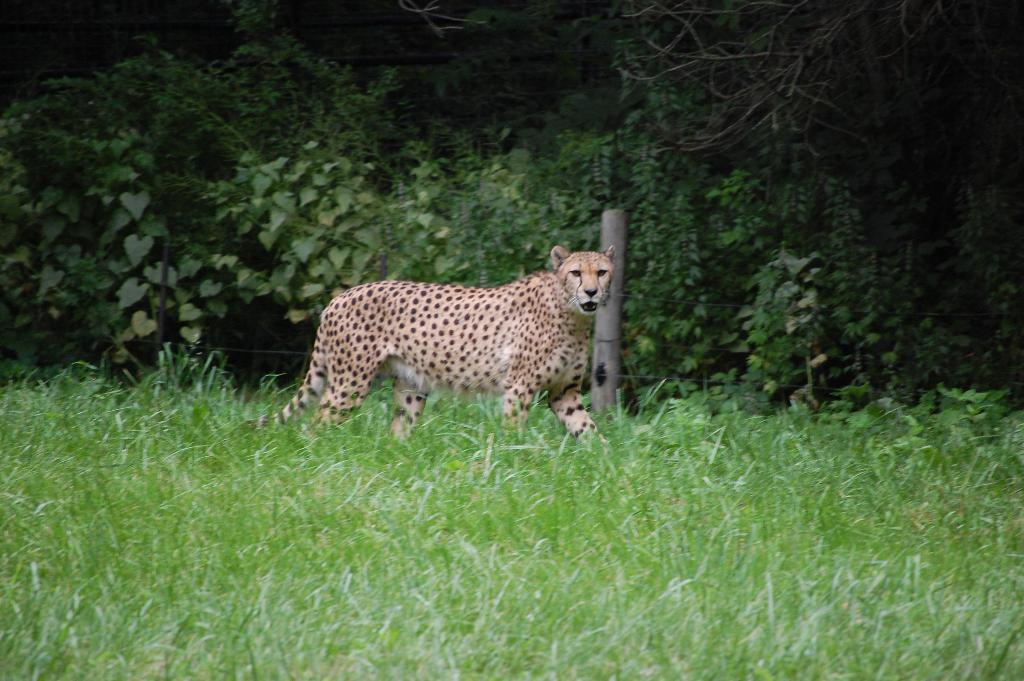What animal is in the image? There is a cheetah in the image. Where is the cheetah located? The cheetah is in the grass. What can be seen in the background of the image? There are green plants in the background of the image. What type of soup is being served in the image? There is no soup present in the image; it features a cheetah in the grass with green plants in the background. Can you describe the chair that the cheetah is sitting on in the image? There is no chair present in the image; the cheetah is in the grass. 